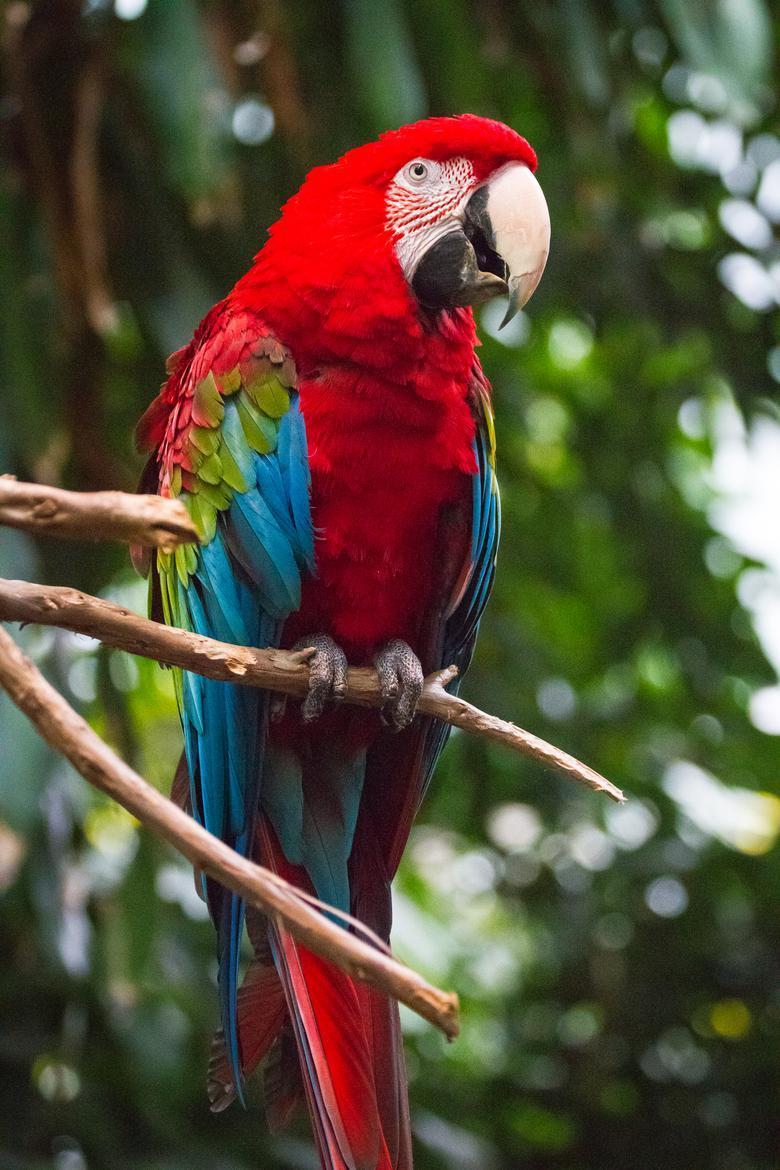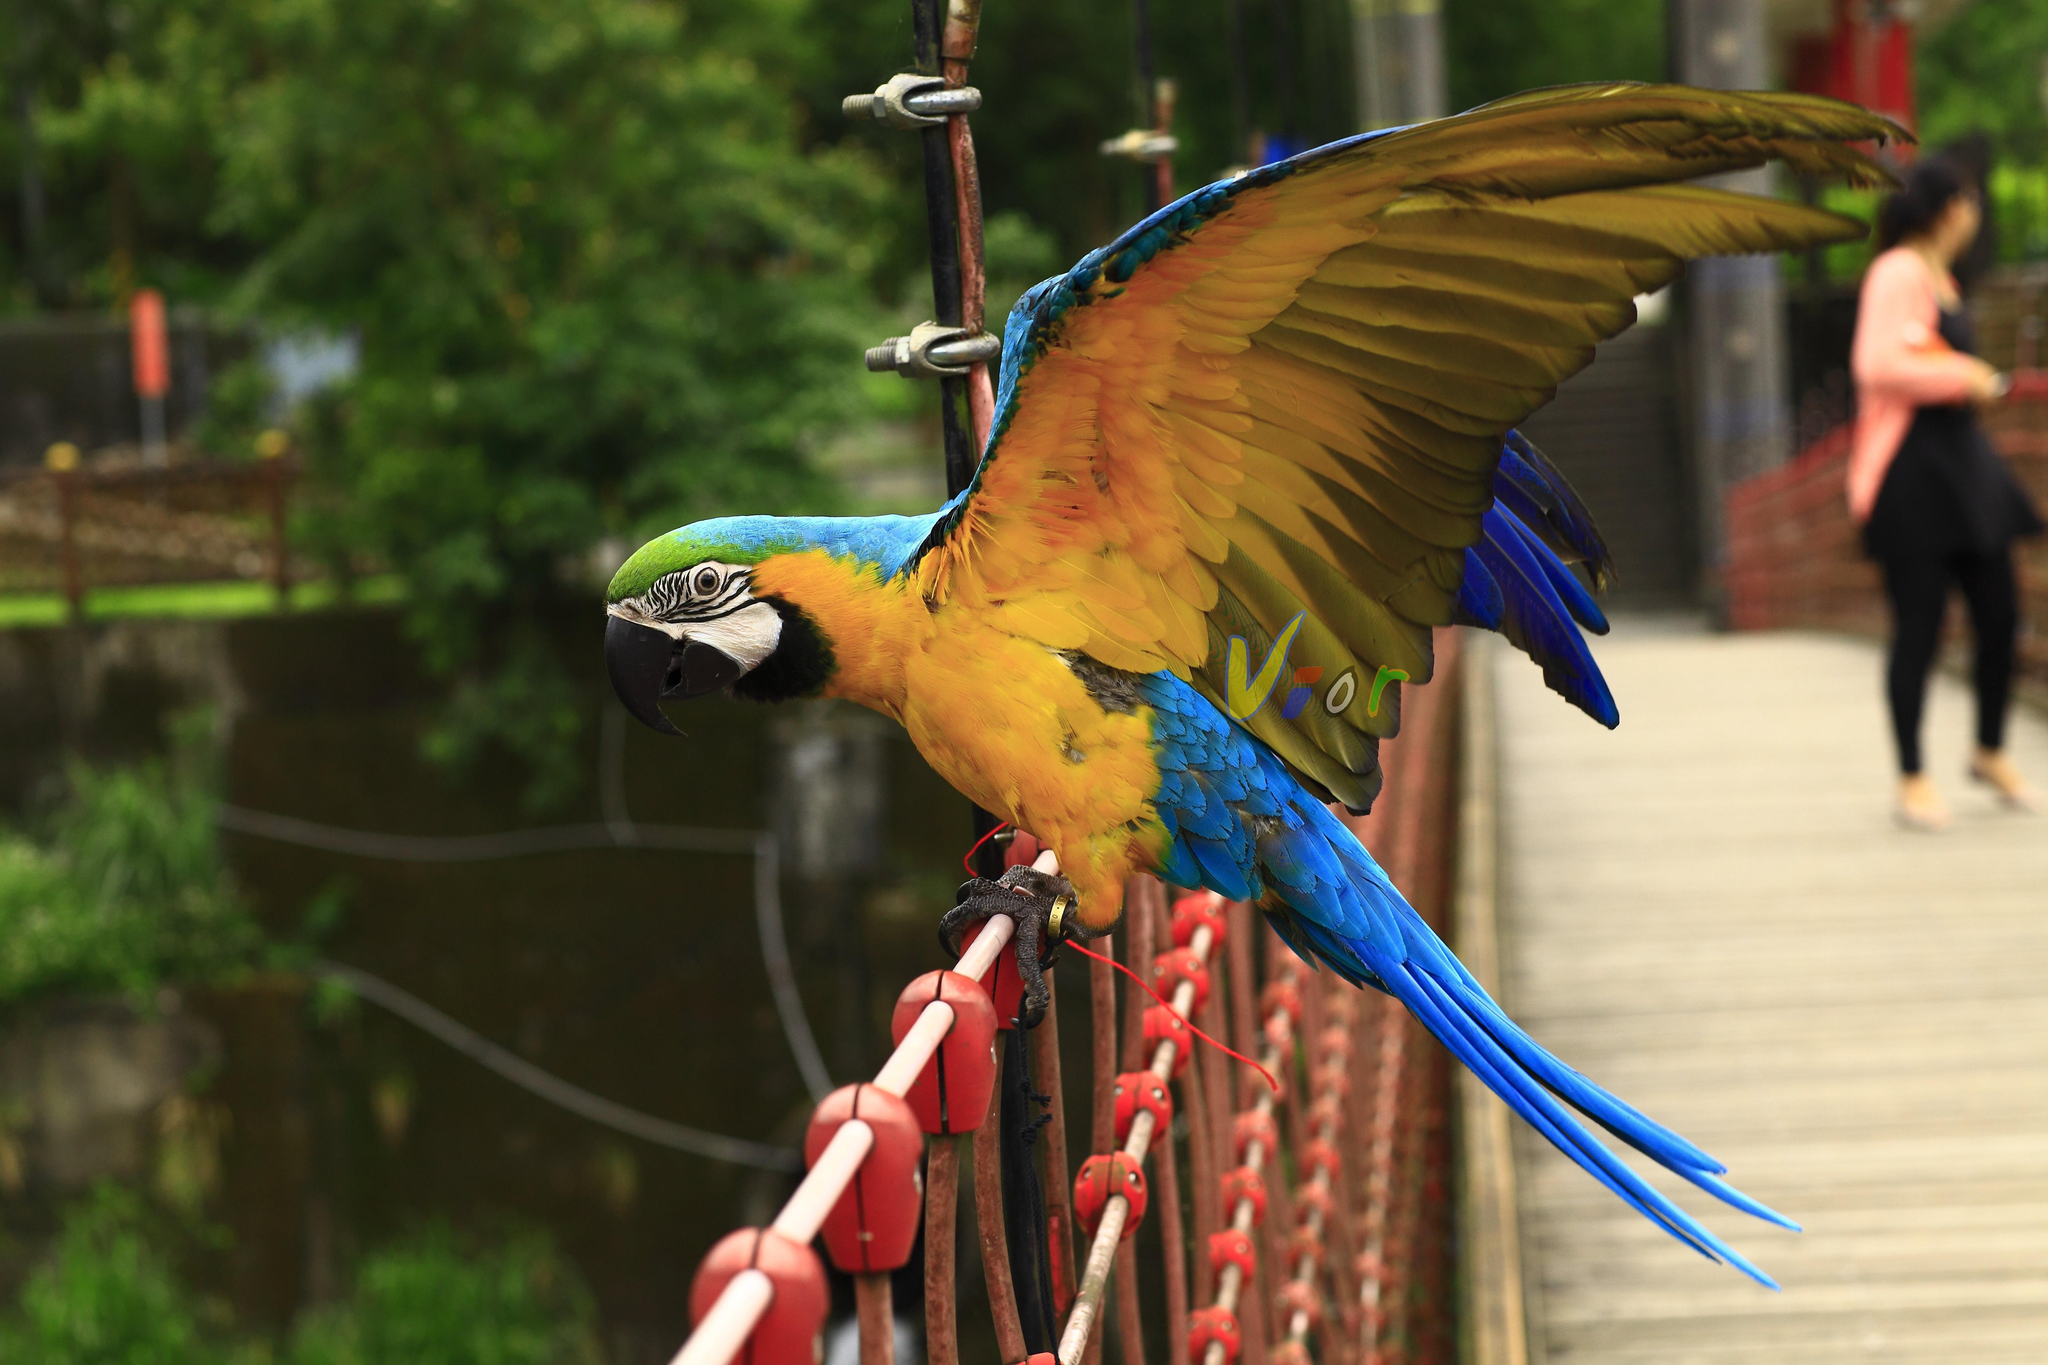The first image is the image on the left, the second image is the image on the right. Considering the images on both sides, is "One image contains a bird with spread wings, and the other image shows a perching bird with a red head." valid? Answer yes or no. Yes. The first image is the image on the left, the second image is the image on the right. Analyze the images presented: Is the assertion "The bird in the image on the right has its wings spread." valid? Answer yes or no. Yes. 